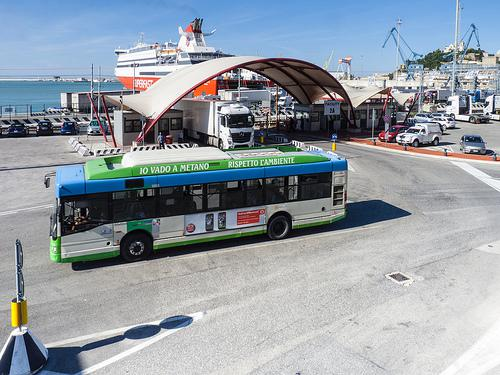Question: what is covering the truck?
Choices:
A. A blanket.
B. A tarp.
C. A cloth.
D. A table cloth.
Answer with the letter. Answer: B 